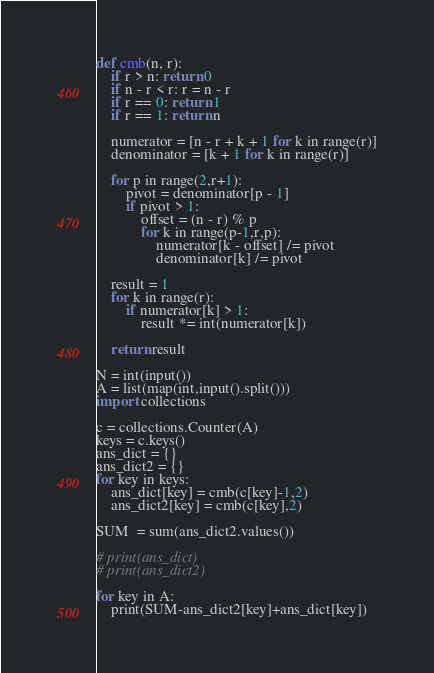<code> <loc_0><loc_0><loc_500><loc_500><_Python_>def cmb(n, r):
    if r > n: return 0
    if n - r < r: r = n - r
    if r == 0: return 1
    if r == 1: return n

    numerator = [n - r + k + 1 for k in range(r)]
    denominator = [k + 1 for k in range(r)]

    for p in range(2,r+1):
        pivot = denominator[p - 1]
        if pivot > 1:
            offset = (n - r) % p
            for k in range(p-1,r,p):
                numerator[k - offset] /= pivot
                denominator[k] /= pivot

    result = 1
    for k in range(r):
        if numerator[k] > 1:
            result *= int(numerator[k])

    return result

N = int(input())
A = list(map(int,input().split()))
import collections

c = collections.Counter(A)
keys = c.keys()
ans_dict = {}
ans_dict2 = {}
for key in keys:
    ans_dict[key] = cmb(c[key]-1,2)
    ans_dict2[key] = cmb(c[key],2)

SUM  = sum(ans_dict2.values())

# print(ans_dict)
# print(ans_dict2)

for key in A:
    print(SUM-ans_dict2[key]+ans_dict[key])</code> 